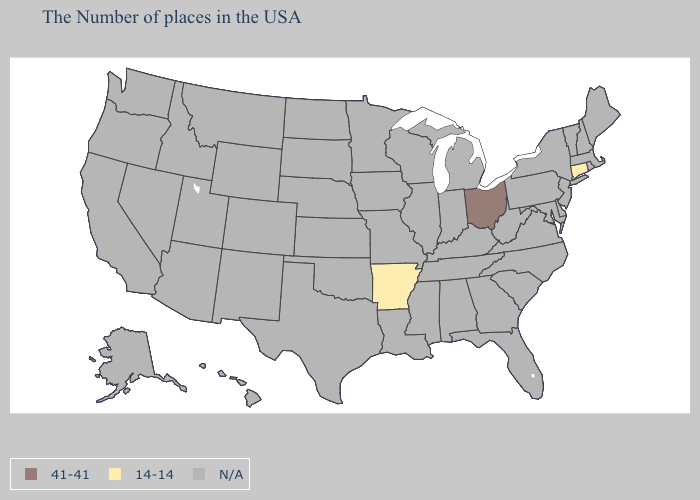Does Connecticut have the highest value in the USA?
Write a very short answer. No. Name the states that have a value in the range 14-14?
Keep it brief. Connecticut, Arkansas. How many symbols are there in the legend?
Give a very brief answer. 3. Which states have the lowest value in the USA?
Write a very short answer. Connecticut, Arkansas. What is the highest value in the USA?
Give a very brief answer. 41-41. What is the highest value in the Northeast ?
Give a very brief answer. 14-14. Name the states that have a value in the range N/A?
Give a very brief answer. Maine, Massachusetts, Rhode Island, New Hampshire, Vermont, New York, New Jersey, Delaware, Maryland, Pennsylvania, Virginia, North Carolina, South Carolina, West Virginia, Florida, Georgia, Michigan, Kentucky, Indiana, Alabama, Tennessee, Wisconsin, Illinois, Mississippi, Louisiana, Missouri, Minnesota, Iowa, Kansas, Nebraska, Oklahoma, Texas, South Dakota, North Dakota, Wyoming, Colorado, New Mexico, Utah, Montana, Arizona, Idaho, Nevada, California, Washington, Oregon, Alaska, Hawaii. What is the value of Kentucky?
Quick response, please. N/A. What is the highest value in the USA?
Be succinct. 41-41. Name the states that have a value in the range 14-14?
Short answer required. Connecticut, Arkansas. What is the value of Missouri?
Be succinct. N/A. 